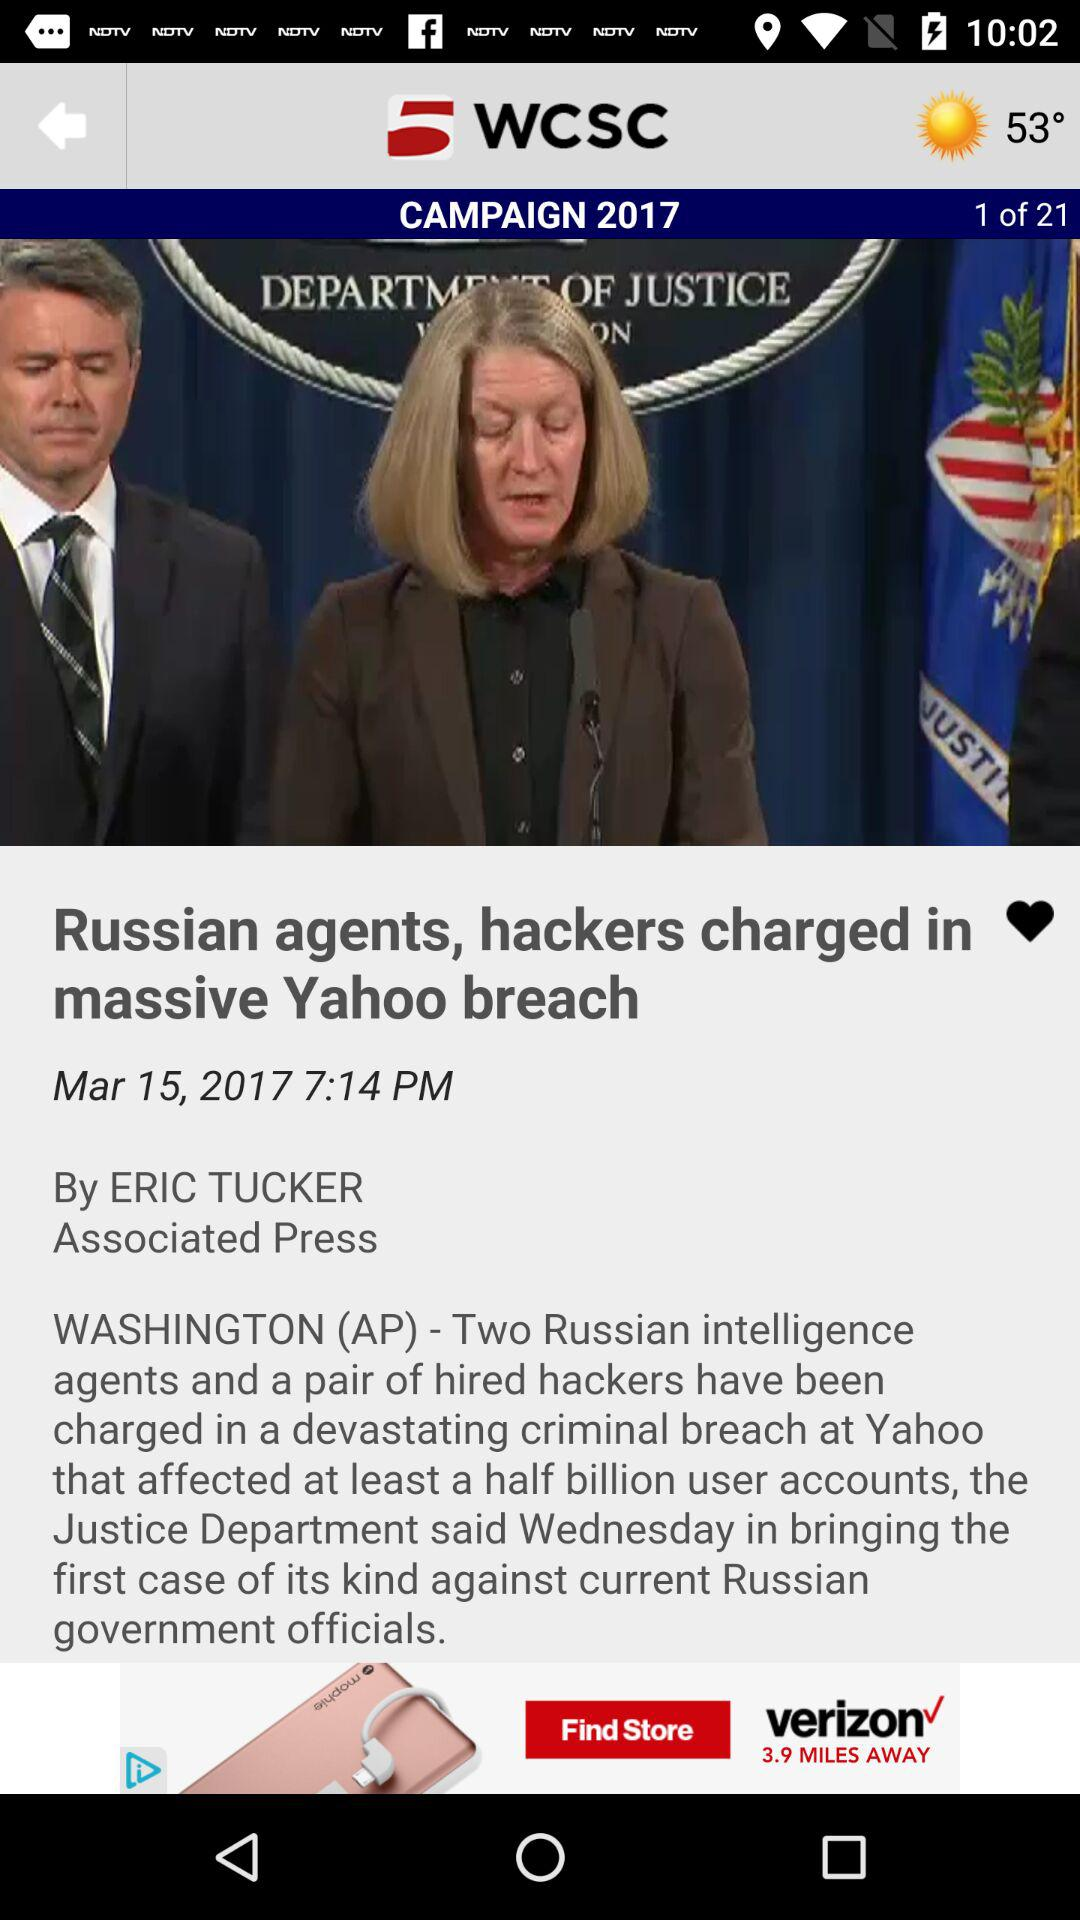Currently we are on what page number? Currently we are on page number 1. 